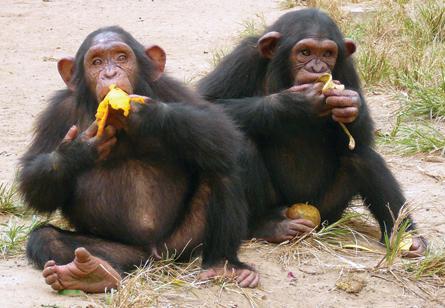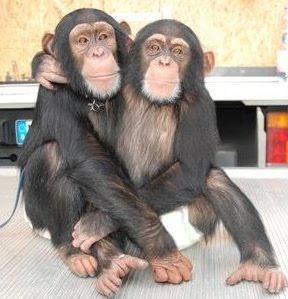The first image is the image on the left, the second image is the image on the right. Examine the images to the left and right. Is the description "There is two chimpanzees in the right image laying down." accurate? Answer yes or no. No. The first image is the image on the left, the second image is the image on the right. For the images shown, is this caption "An image shows a pair of same-sized chimps in a hugging pose." true? Answer yes or no. Yes. 